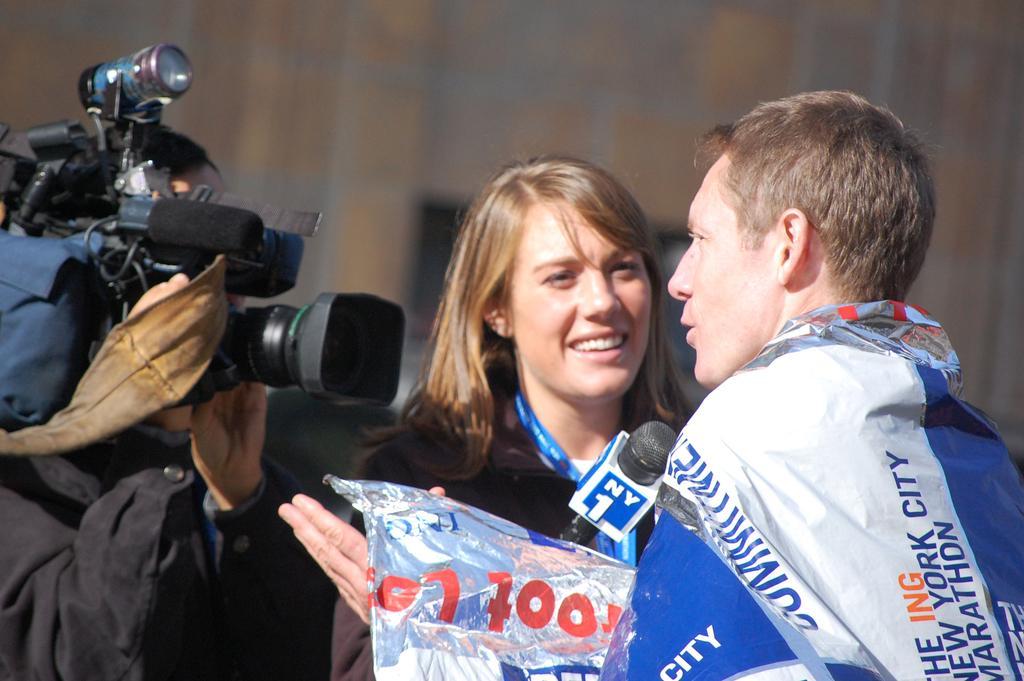How would you summarize this image in a sentence or two? Here we can see a woman and a man. She is holding a mike with her hand. And there is a person holding a camera her hands. 